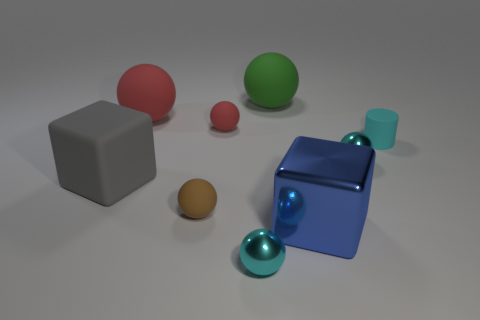What number of other objects are there of the same color as the small matte cylinder?
Provide a succinct answer. 2. Do the brown matte object and the cyan matte object have the same size?
Offer a terse response. Yes. Are there any yellow blocks?
Provide a succinct answer. No. Are there any blocks that have the same material as the brown object?
Keep it short and to the point. Yes. What material is the other cube that is the same size as the matte block?
Keep it short and to the point. Metal. What number of large blue metal objects have the same shape as the gray matte thing?
Make the answer very short. 1. What size is the brown sphere that is the same material as the gray cube?
Provide a short and direct response. Small. What is the material of the thing that is in front of the brown object and left of the green rubber thing?
Your answer should be compact. Metal. How many brown matte spheres are the same size as the blue block?
Make the answer very short. 0. There is a big blue object that is the same shape as the gray object; what is its material?
Make the answer very short. Metal. 